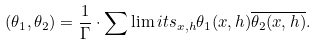<formula> <loc_0><loc_0><loc_500><loc_500>( \theta _ { 1 } , \theta _ { 2 } ) = \frac { 1 } { \Gamma } \cdot \sum \lim i t s _ { x , h } \theta _ { 1 } ( x , h ) \overline { \theta _ { 2 } ( x , h ) } .</formula> 